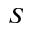<formula> <loc_0><loc_0><loc_500><loc_500>S</formula> 